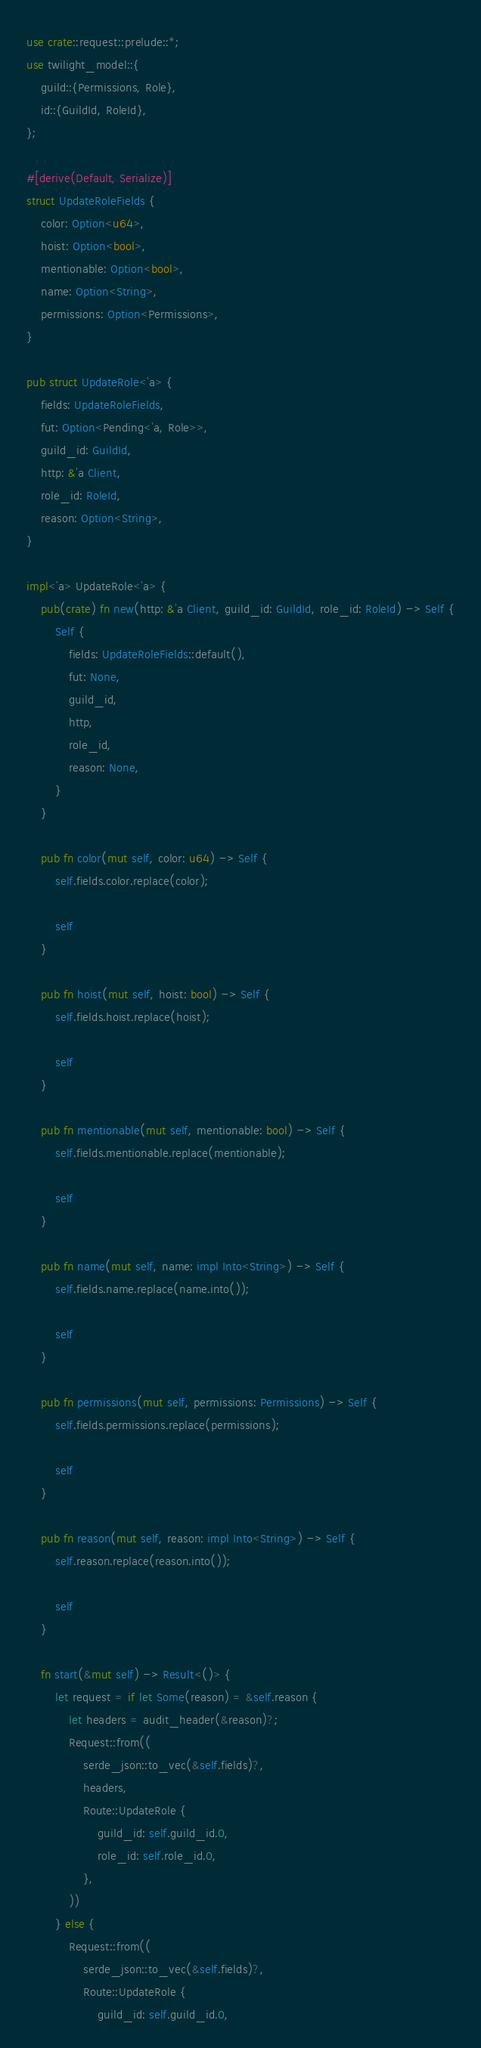<code> <loc_0><loc_0><loc_500><loc_500><_Rust_>use crate::request::prelude::*;
use twilight_model::{
    guild::{Permissions, Role},
    id::{GuildId, RoleId},
};

#[derive(Default, Serialize)]
struct UpdateRoleFields {
    color: Option<u64>,
    hoist: Option<bool>,
    mentionable: Option<bool>,
    name: Option<String>,
    permissions: Option<Permissions>,
}

pub struct UpdateRole<'a> {
    fields: UpdateRoleFields,
    fut: Option<Pending<'a, Role>>,
    guild_id: GuildId,
    http: &'a Client,
    role_id: RoleId,
    reason: Option<String>,
}

impl<'a> UpdateRole<'a> {
    pub(crate) fn new(http: &'a Client, guild_id: GuildId, role_id: RoleId) -> Self {
        Self {
            fields: UpdateRoleFields::default(),
            fut: None,
            guild_id,
            http,
            role_id,
            reason: None,
        }
    }

    pub fn color(mut self, color: u64) -> Self {
        self.fields.color.replace(color);

        self
    }

    pub fn hoist(mut self, hoist: bool) -> Self {
        self.fields.hoist.replace(hoist);

        self
    }

    pub fn mentionable(mut self, mentionable: bool) -> Self {
        self.fields.mentionable.replace(mentionable);

        self
    }

    pub fn name(mut self, name: impl Into<String>) -> Self {
        self.fields.name.replace(name.into());

        self
    }

    pub fn permissions(mut self, permissions: Permissions) -> Self {
        self.fields.permissions.replace(permissions);

        self
    }

    pub fn reason(mut self, reason: impl Into<String>) -> Self {
        self.reason.replace(reason.into());

        self
    }

    fn start(&mut self) -> Result<()> {
        let request = if let Some(reason) = &self.reason {
            let headers = audit_header(&reason)?;
            Request::from((
                serde_json::to_vec(&self.fields)?,
                headers,
                Route::UpdateRole {
                    guild_id: self.guild_id.0,
                    role_id: self.role_id.0,
                },
            ))
        } else {
            Request::from((
                serde_json::to_vec(&self.fields)?,
                Route::UpdateRole {
                    guild_id: self.guild_id.0,</code> 